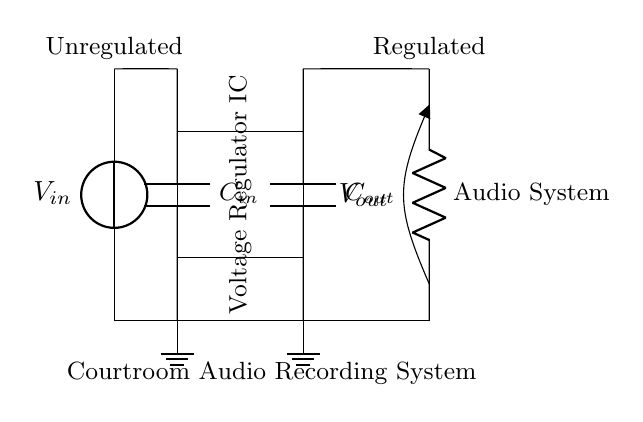What is the input voltage of the circuit? The input voltage is labeled as V in, which is the voltage source connected to the circuit providing the unregulated input.
Answer: V in What type of component is the rectangle labeled as Voltage Regulator IC? The rectangle represents an integrated circuit specifically designed to maintain a steady output voltage regardless of changes in the input voltage or load conditions.
Answer: Voltage Regulator IC How many capacitors are in this circuit? There are two capacitors indicated, one labeled as C in and the other as C out, both of which are essential for stabilizing the voltage in the circuit.
Answer: Two What is the purpose of C out? The output capacitor C out helps smooth the output voltage to prevent fluctuations, ensuring a stable power supply to the audio recording system.
Answer: Smoothing What happens to the voltage when it passes through the regulator? The voltage is regulated, meaning it is maintained at a consistent level, preventing any spikes or drops that could affect the performance of the audio recording system.
Answer: Maintained What does the load resistor represent in the circuit? The load resistor is labeled as the audio system, indicating that it represents the actual load the voltage regulator is supplying power to in this scenario.
Answer: Audio System 